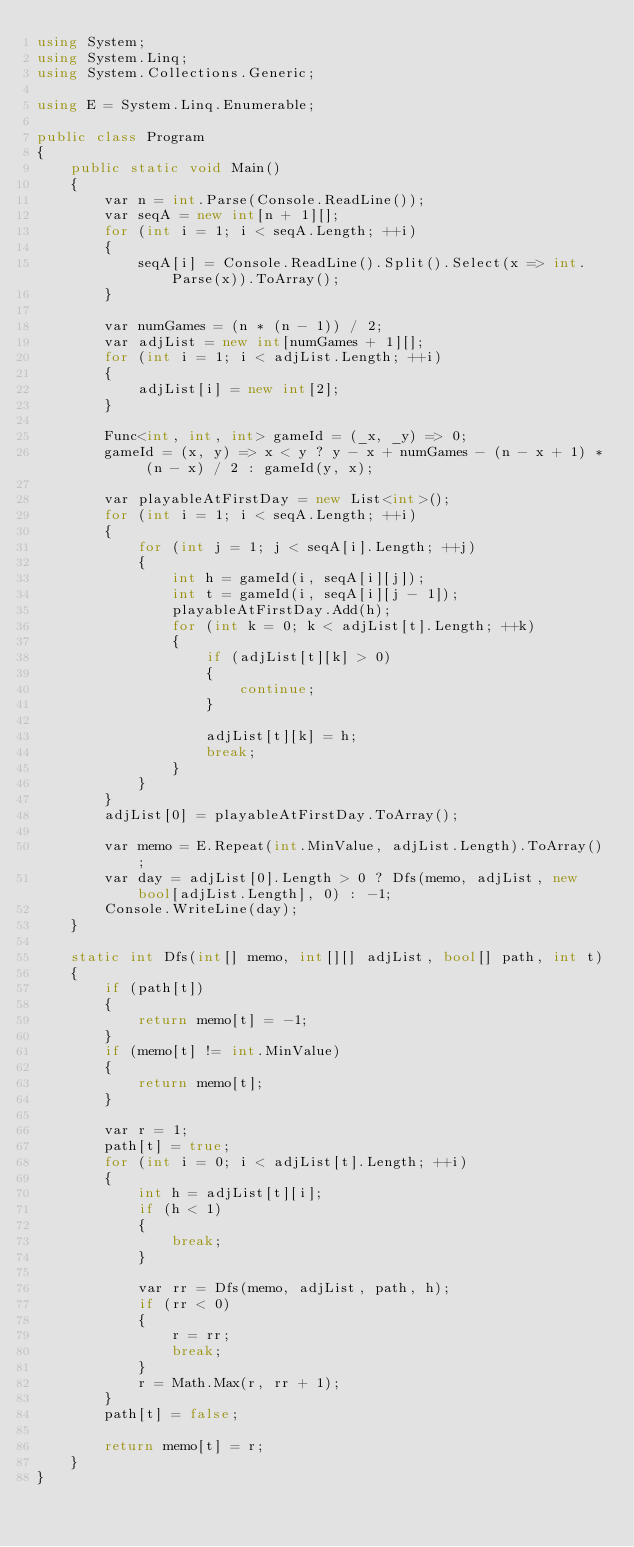Convert code to text. <code><loc_0><loc_0><loc_500><loc_500><_C#_>using System;
using System.Linq;
using System.Collections.Generic;

using E = System.Linq.Enumerable;

public class Program
{
    public static void Main()
    {
        var n = int.Parse(Console.ReadLine());
        var seqA = new int[n + 1][];
        for (int i = 1; i < seqA.Length; ++i)
        {
            seqA[i] = Console.ReadLine().Split().Select(x => int.Parse(x)).ToArray();
        }

        var numGames = (n * (n - 1)) / 2;
        var adjList = new int[numGames + 1][];
        for (int i = 1; i < adjList.Length; ++i)
        {
            adjList[i] = new int[2];
        }

        Func<int, int, int> gameId = (_x, _y) => 0;
        gameId = (x, y) => x < y ? y - x + numGames - (n - x + 1) * (n - x) / 2 : gameId(y, x);

        var playableAtFirstDay = new List<int>();
        for (int i = 1; i < seqA.Length; ++i)
        {
            for (int j = 1; j < seqA[i].Length; ++j)
            {
                int h = gameId(i, seqA[i][j]);
                int t = gameId(i, seqA[i][j - 1]);
                playableAtFirstDay.Add(h);
                for (int k = 0; k < adjList[t].Length; ++k)
                {
                    if (adjList[t][k] > 0)
                    {
                        continue;
                    }

                    adjList[t][k] = h;
                    break;
                }
            }
        }
        adjList[0] = playableAtFirstDay.ToArray();

        var memo = E.Repeat(int.MinValue, adjList.Length).ToArray();
        var day = adjList[0].Length > 0 ? Dfs(memo, adjList, new bool[adjList.Length], 0) : -1;
        Console.WriteLine(day);
    }

    static int Dfs(int[] memo, int[][] adjList, bool[] path, int t)
    {
        if (path[t])
        {
            return memo[t] = -1;
        }
        if (memo[t] != int.MinValue)
        {
            return memo[t];
        }

        var r = 1;
        path[t] = true;
        for (int i = 0; i < adjList[t].Length; ++i)
        {
            int h = adjList[t][i];
            if (h < 1)
            {
                break;
            }
            
            var rr = Dfs(memo, adjList, path, h);
            if (rr < 0)
            {
                r = rr;
                break;
            }
            r = Math.Max(r, rr + 1);
        }
        path[t] = false;

        return memo[t] = r;
    }
}
</code> 